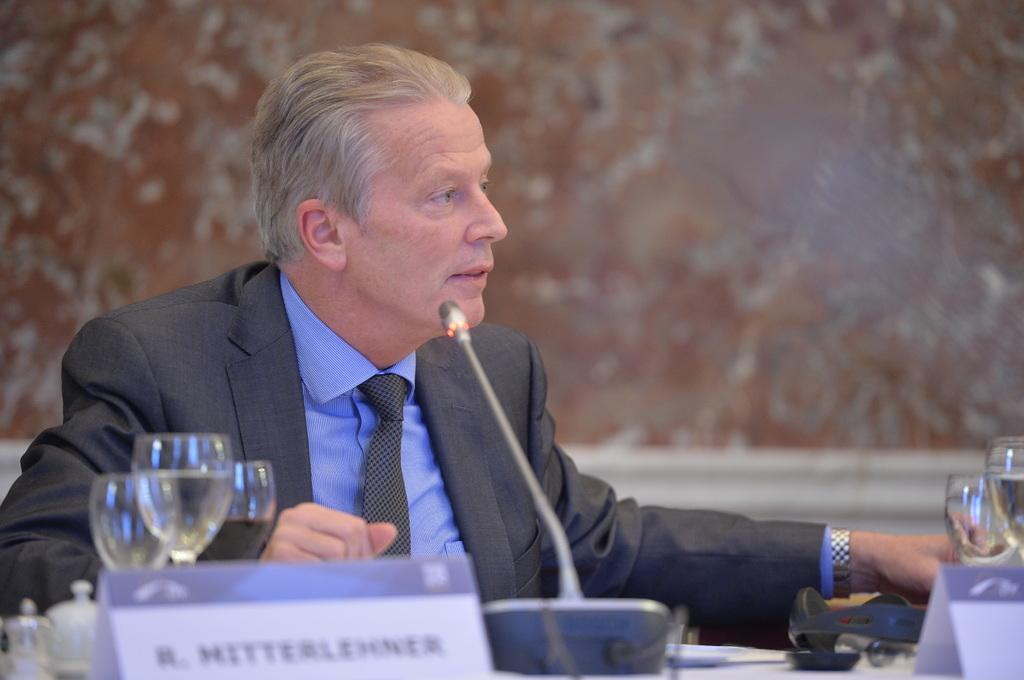What is the person in the image doing? The person is seated in the image. What is in front of the seated person? There is a table in front of the person. What can be seen on the table? A mic and glasses with drinks are present on the table. What might be used to identify the person in the image? There is a name board in the image. What type of elbow is visible in the image? There is no elbow present in the image. How many bottles are on the table in the image? There is no bottle mentioned in the provided facts, so it cannot be determined from the image. 